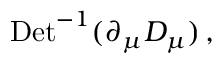<formula> <loc_0><loc_0><loc_500><loc_500>D e t ^ { - 1 } ( \partial _ { \mu } D _ { \mu } ) \, ,</formula> 